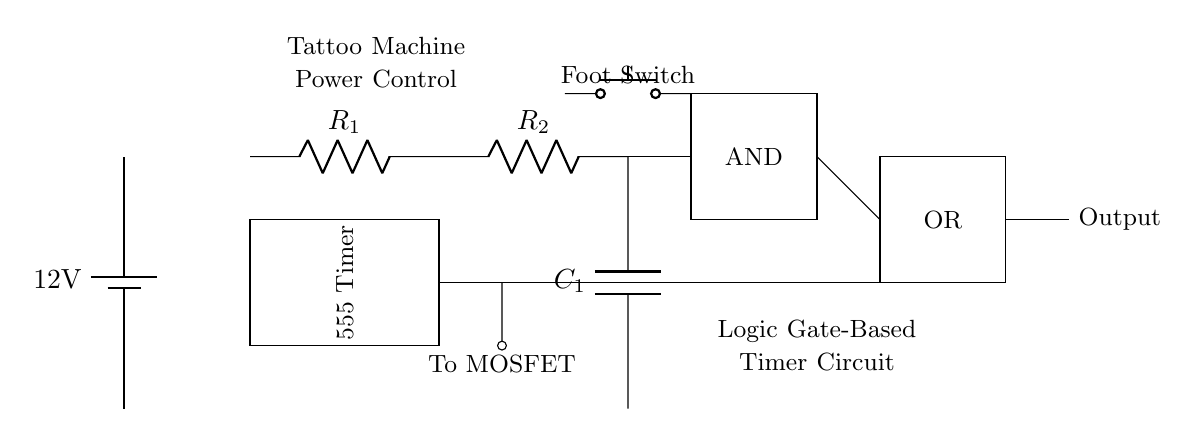What is the voltage of the power supply? The circuit shows a battery labeled with a voltage of 12 volts, indicating the power supply voltage.
Answer: 12 volts What components are used for timing in the circuit? The timing components in the circuit are denoted by R1, R2, and C1. R1 and R2 are resistors, while C1 is a capacitor.
Answer: R1, R2, C1 What triggers the logic gates in this circuit? The foot switch is connecting to the AND gate, which indicates that pressing the switch initiates the control process for the logic gates.
Answer: Foot switch Which logic gate is present in the circuit? The circuit contains an AND gate and an OR gate, clearly labeled within rectangles. The AND gate is positioned before the OR gate.
Answer: AND gate, OR gate What is the output connected to in this circuit? The output of the OR gate connects to another element, specifically indicated as "To MOSFET," showing that this is where the control mechanism progresses.
Answer: To MOSFET How many resistors are used in the timing section? The drawing displays two resistors labeled R1 and R2 located in series for timing purposes around the capacitor C1.
Answer: Two resistors What function does the 555 timer perform in this circuit? The 555 timer is typically employed in timing circuits as a monostable or astable multivibrator, controlling the output pulse duration for the tattoo machine power control.
Answer: Timer 